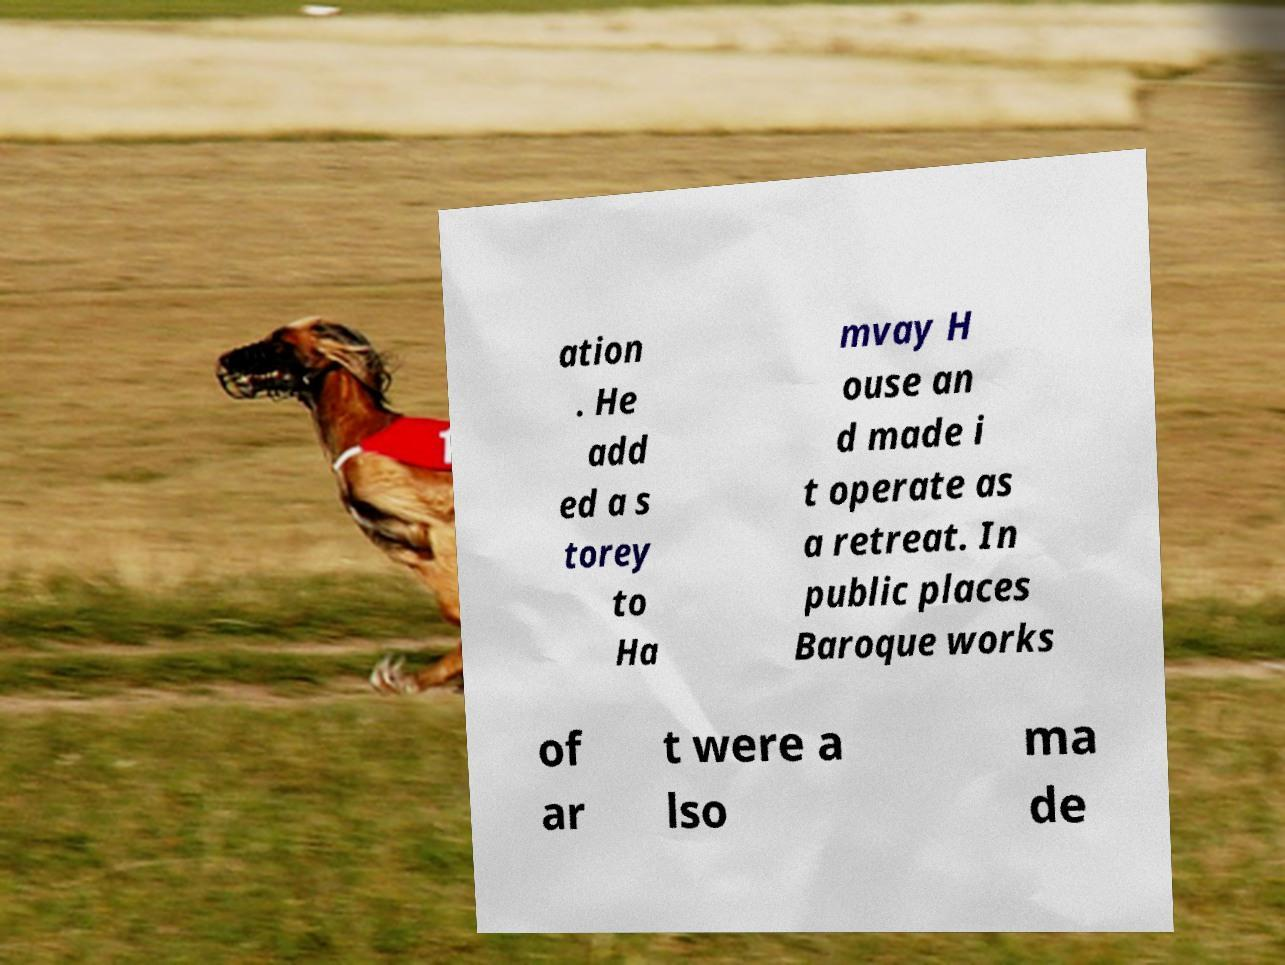There's text embedded in this image that I need extracted. Can you transcribe it verbatim? ation . He add ed a s torey to Ha mvay H ouse an d made i t operate as a retreat. In public places Baroque works of ar t were a lso ma de 